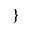Convert formula to latex. <formula><loc_0><loc_0><loc_500><loc_500>\}</formula> 